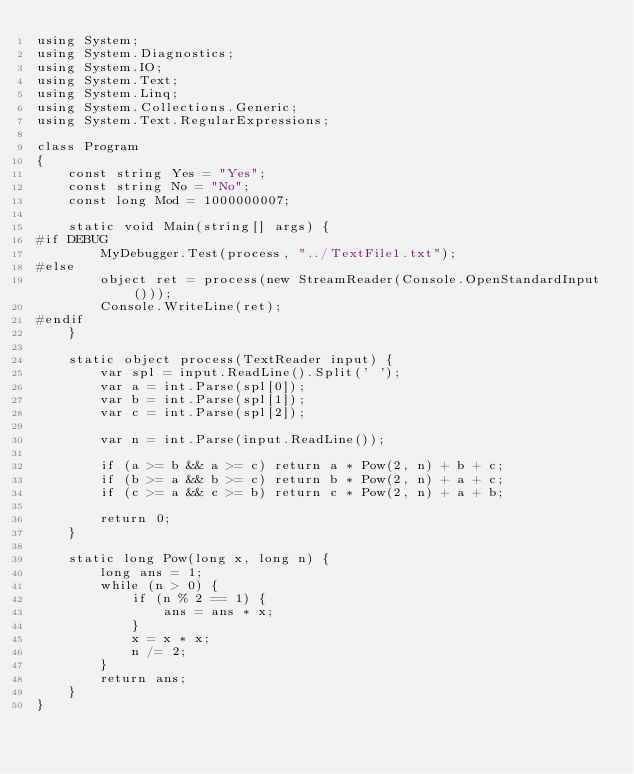Convert code to text. <code><loc_0><loc_0><loc_500><loc_500><_C#_>using System;
using System.Diagnostics;
using System.IO;
using System.Text;
using System.Linq;
using System.Collections.Generic;
using System.Text.RegularExpressions;

class Program
{
    const string Yes = "Yes";
    const string No = "No";
    const long Mod = 1000000007;

    static void Main(string[] args) {
#if DEBUG
        MyDebugger.Test(process, "../TextFile1.txt");
#else
        object ret = process(new StreamReader(Console.OpenStandardInput()));
        Console.WriteLine(ret);
#endif
    }

    static object process(TextReader input) {
        var spl = input.ReadLine().Split(' ');
        var a = int.Parse(spl[0]);
        var b = int.Parse(spl[1]);
        var c = int.Parse(spl[2]);

        var n = int.Parse(input.ReadLine());

        if (a >= b && a >= c) return a * Pow(2, n) + b + c;
        if (b >= a && b >= c) return b * Pow(2, n) + a + c;
        if (c >= a && c >= b) return c * Pow(2, n) + a + b;

        return 0;
    }

    static long Pow(long x, long n) {
        long ans = 1;
        while (n > 0) {
            if (n % 2 == 1) {
                ans = ans * x;
            }
            x = x * x;
            n /= 2;
        }
        return ans;
    }
}
</code> 